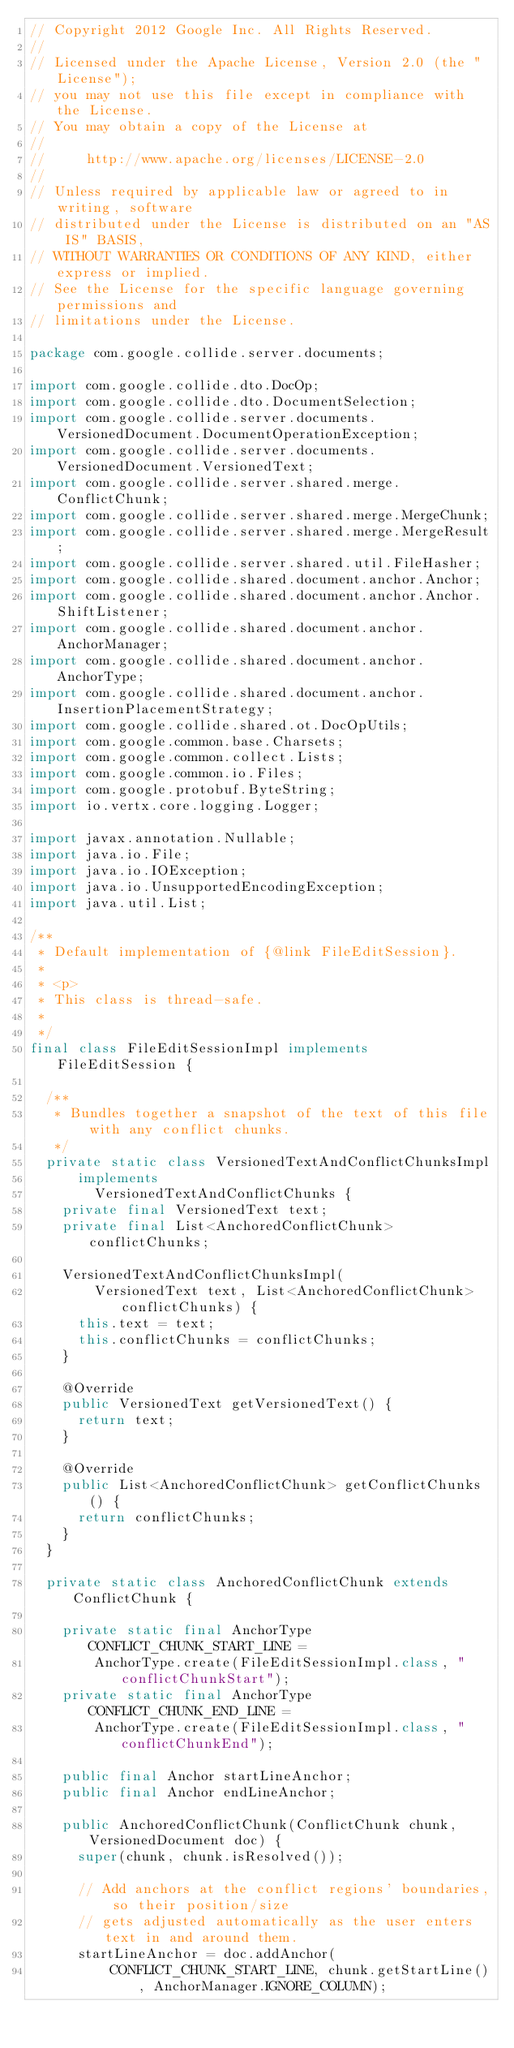<code> <loc_0><loc_0><loc_500><loc_500><_Java_>// Copyright 2012 Google Inc. All Rights Reserved.
//
// Licensed under the Apache License, Version 2.0 (the "License");
// you may not use this file except in compliance with the License.
// You may obtain a copy of the License at
//
//     http://www.apache.org/licenses/LICENSE-2.0
//
// Unless required by applicable law or agreed to in writing, software
// distributed under the License is distributed on an "AS IS" BASIS,
// WITHOUT WARRANTIES OR CONDITIONS OF ANY KIND, either express or implied.
// See the License for the specific language governing permissions and
// limitations under the License.

package com.google.collide.server.documents;

import com.google.collide.dto.DocOp;
import com.google.collide.dto.DocumentSelection;
import com.google.collide.server.documents.VersionedDocument.DocumentOperationException;
import com.google.collide.server.documents.VersionedDocument.VersionedText;
import com.google.collide.server.shared.merge.ConflictChunk;
import com.google.collide.server.shared.merge.MergeChunk;
import com.google.collide.server.shared.merge.MergeResult;
import com.google.collide.server.shared.util.FileHasher;
import com.google.collide.shared.document.anchor.Anchor;
import com.google.collide.shared.document.anchor.Anchor.ShiftListener;
import com.google.collide.shared.document.anchor.AnchorManager;
import com.google.collide.shared.document.anchor.AnchorType;
import com.google.collide.shared.document.anchor.InsertionPlacementStrategy;
import com.google.collide.shared.ot.DocOpUtils;
import com.google.common.base.Charsets;
import com.google.common.collect.Lists;
import com.google.common.io.Files;
import com.google.protobuf.ByteString;
import io.vertx.core.logging.Logger;

import javax.annotation.Nullable;
import java.io.File;
import java.io.IOException;
import java.io.UnsupportedEncodingException;
import java.util.List;

/**
 * Default implementation of {@link FileEditSession}.
 *
 * <p>
 * This class is thread-safe.
 *
 */
final class FileEditSessionImpl implements FileEditSession {

  /**
   * Bundles together a snapshot of the text of this file with any conflict chunks.
   */
  private static class VersionedTextAndConflictChunksImpl
      implements
        VersionedTextAndConflictChunks {
    private final VersionedText text;
    private final List<AnchoredConflictChunk> conflictChunks;

    VersionedTextAndConflictChunksImpl(
        VersionedText text, List<AnchoredConflictChunk> conflictChunks) {
      this.text = text;
      this.conflictChunks = conflictChunks;
    }

    @Override
    public VersionedText getVersionedText() {
      return text;
    }

    @Override
    public List<AnchoredConflictChunk> getConflictChunks() {
      return conflictChunks;
    }
  }

  private static class AnchoredConflictChunk extends ConflictChunk {

    private static final AnchorType CONFLICT_CHUNK_START_LINE =
        AnchorType.create(FileEditSessionImpl.class, "conflictChunkStart");
    private static final AnchorType CONFLICT_CHUNK_END_LINE =
        AnchorType.create(FileEditSessionImpl.class, "conflictChunkEnd");

    public final Anchor startLineAnchor;
    public final Anchor endLineAnchor;

    public AnchoredConflictChunk(ConflictChunk chunk, VersionedDocument doc) {
      super(chunk, chunk.isResolved());

      // Add anchors at the conflict regions' boundaries, so their position/size
      // gets adjusted automatically as the user enters text in and around them.
      startLineAnchor = doc.addAnchor(
          CONFLICT_CHUNK_START_LINE, chunk.getStartLine(), AnchorManager.IGNORE_COLUMN);</code> 